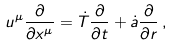Convert formula to latex. <formula><loc_0><loc_0><loc_500><loc_500>u ^ { \mu } \frac { \partial } { \partial x ^ { \mu } } = { \dot { T } } \frac { \partial } { \partial t } + { \dot { a } } \frac { \partial } { \partial r } \, ,</formula> 